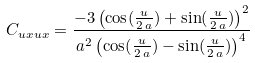Convert formula to latex. <formula><loc_0><loc_0><loc_500><loc_500>C _ { u x u x } = { \frac { - 3 \, { { \left ( \cos ( { \frac { u } { 2 \, a } } ) + \sin ( { \frac { u } { 2 \, a } } ) \right ) } ^ { 2 } } } { { a ^ { 2 } } \, { { \left ( \cos ( { \frac { u } { 2 \, a } } ) - \sin ( { \frac { u } { 2 \, a } } ) \right ) } ^ { 4 } } } }</formula> 